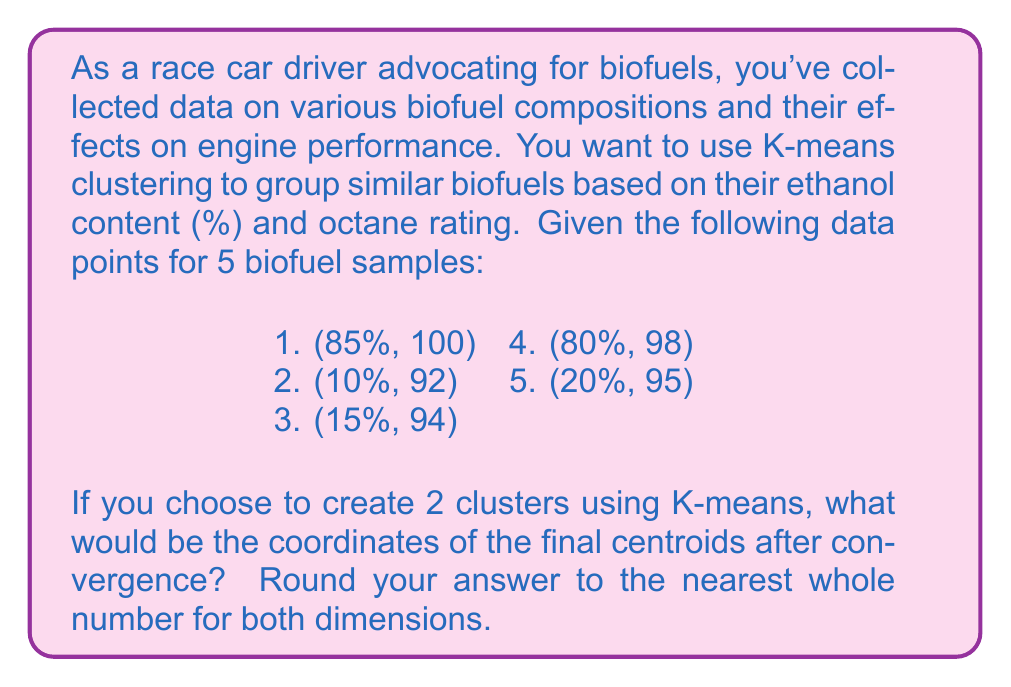Teach me how to tackle this problem. To solve this problem using K-means clustering, we'll follow these steps:

1. Initialize two centroids randomly. Let's choose (85%, 100) and (10%, 92) as our initial centroids.

2. Assign each data point to the nearest centroid:
   Cluster 1 (85%, 100): (85%, 100), (80%, 98)
   Cluster 2 (10%, 92): (10%, 92), (15%, 94), (20%, 95)

3. Recalculate the centroids by taking the mean of all points in each cluster:
   Cluster 1: $(\frac{85 + 80}{2}, \frac{100 + 98}{2}) = (82.5, 99)$
   Cluster 2: $(\frac{10 + 15 + 20}{3}, \frac{92 + 94 + 95}{3}) = (15, 93.67)$

4. Reassign points to the new centroids:
   Cluster 1 (82.5, 99): (85%, 100), (80%, 98)
   Cluster 2 (15, 93.67): (10%, 92), (15%, 94), (20%, 95)

5. Recalculate the centroids:
   Cluster 1: $(\frac{85 + 80}{2}, \frac{100 + 98}{2}) = (82.5, 99)$
   Cluster 2: $(\frac{10 + 15 + 20}{3}, \frac{92 + 94 + 95}{3}) = (15, 93.67)$

The centroids remain the same after this iteration, so the algorithm has converged.

Rounding to the nearest whole number:
Cluster 1: (83, 99)
Cluster 2: (15, 94)
Answer: The final centroids after convergence, rounded to the nearest whole number, are (83, 99) and (15, 94). 